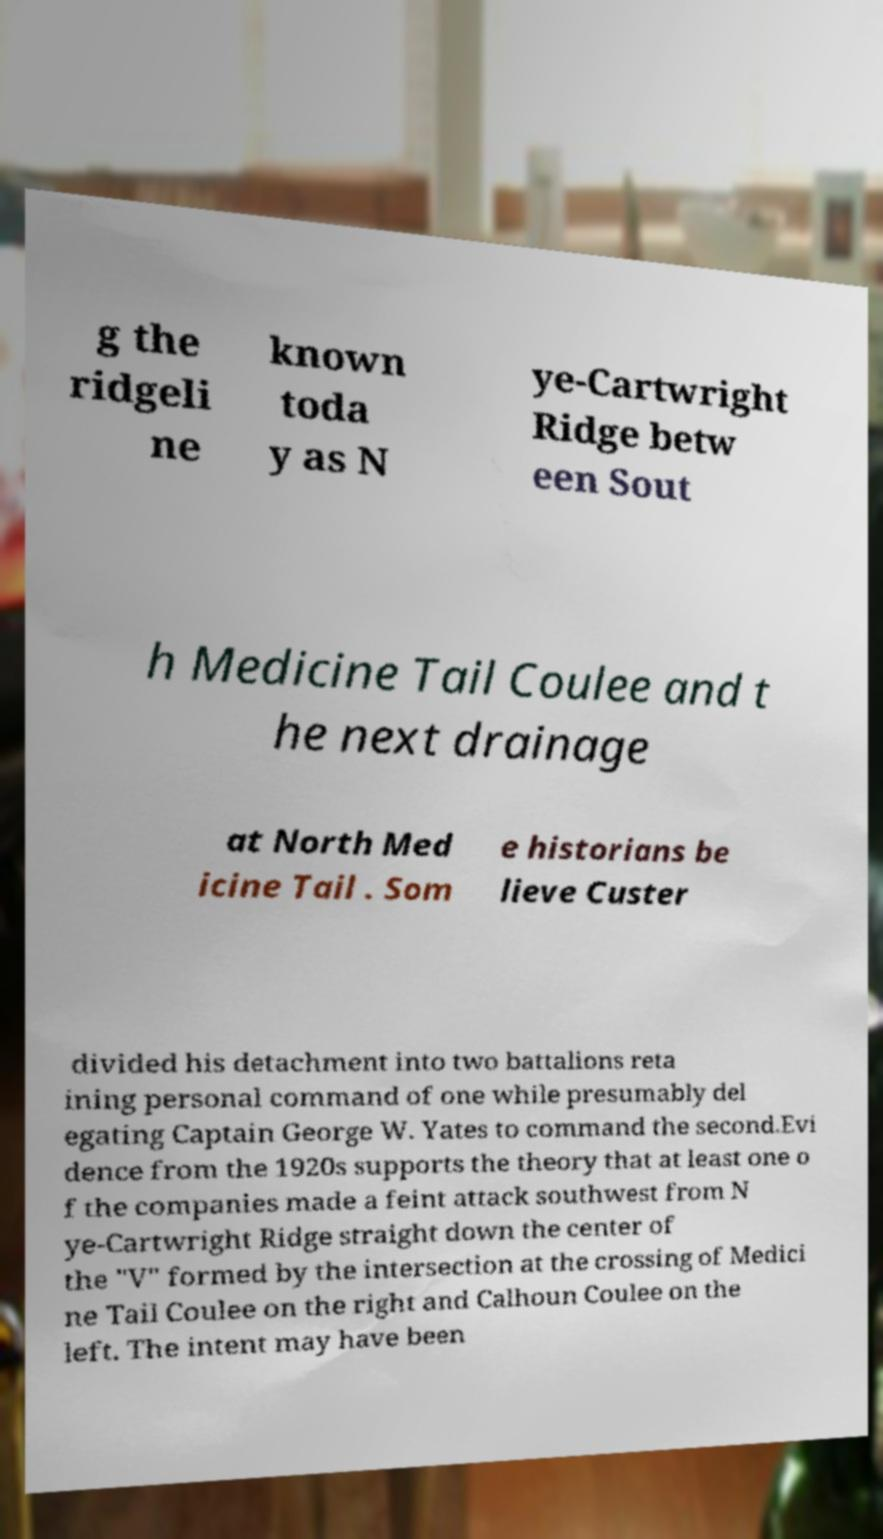Could you extract and type out the text from this image? g the ridgeli ne known toda y as N ye-Cartwright Ridge betw een Sout h Medicine Tail Coulee and t he next drainage at North Med icine Tail . Som e historians be lieve Custer divided his detachment into two battalions reta ining personal command of one while presumably del egating Captain George W. Yates to command the second.Evi dence from the 1920s supports the theory that at least one o f the companies made a feint attack southwest from N ye-Cartwright Ridge straight down the center of the "V" formed by the intersection at the crossing of Medici ne Tail Coulee on the right and Calhoun Coulee on the left. The intent may have been 